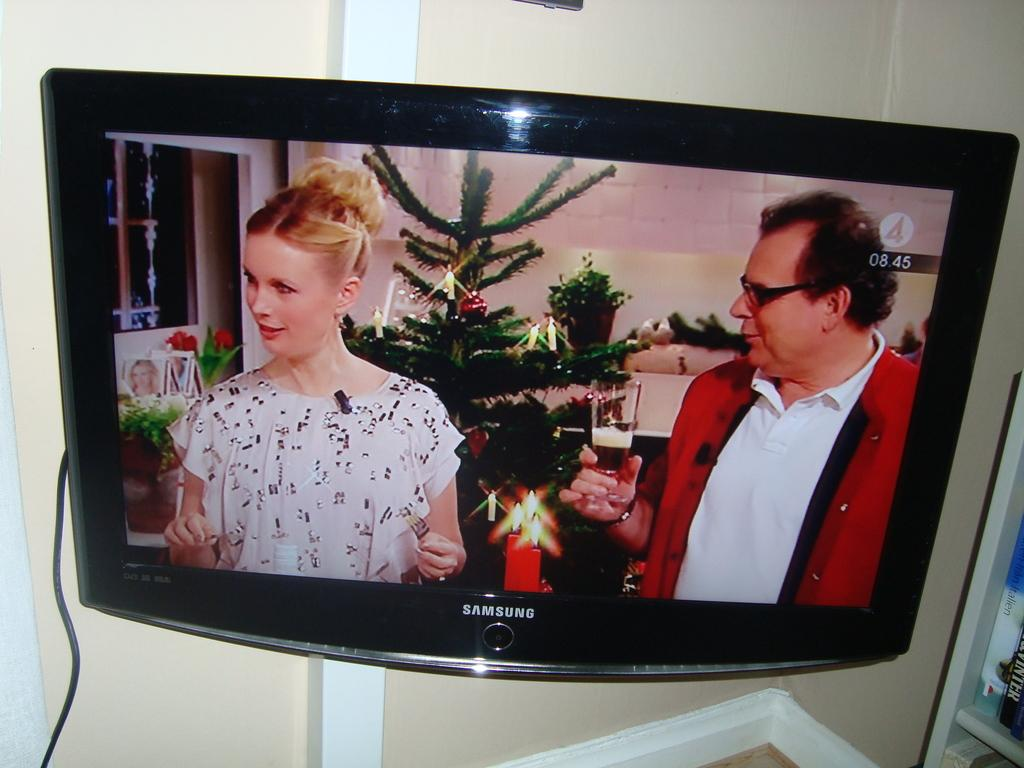<image>
Render a clear and concise summary of the photo. samsung tv showing two people in front of a christmas tree and in upper right corner number 4 and time of 8:45 